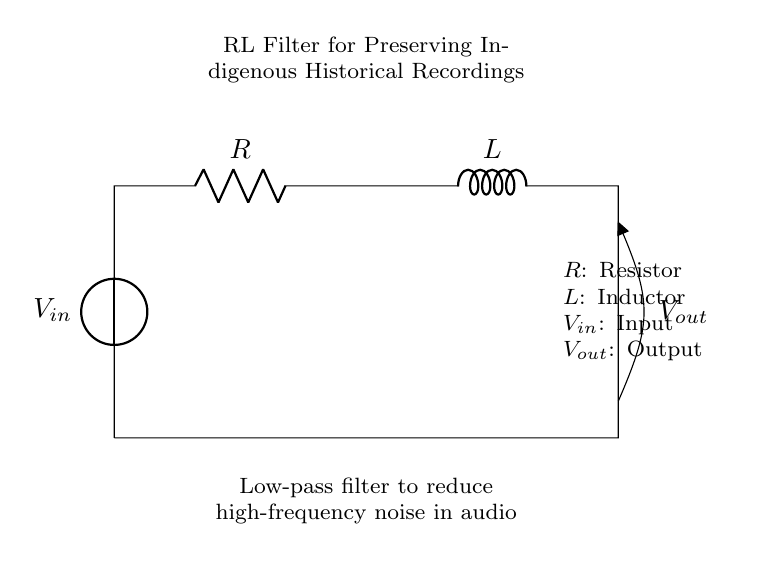What is the type of filter used in this circuit? The circuit uses a low-pass filter, as indicated by the design with a resistor and inductor, which allows low-frequency signals to pass while attenuating high-frequency signals.
Answer: Low-pass filter What component is labeled as 'R'? The component labeled 'R' is a resistor, which is used to limit the current flow in the circuit.
Answer: Resistor What component is labeled as 'L'? The component labeled 'L' is an inductor, which stores energy in a magnetic field when electrical current passes through it.
Answer: Inductor What is the significance of 'Vout' in this circuit? 'Vout' represents the output voltage of the circuit, which is taken across the inductor and indicates the filtered audio signal after passing through the low-pass filter.
Answer: Output voltage Why is a low-pass filter important for historical recordings? A low-pass filter is crucial for removing high-frequency noise from historical audio recordings, helping to preserve the clarity and quality of sounds relevant to indigenous cultures.
Answer: Preserves quality What happens to high-frequency signals in this circuit? High-frequency signals are attenuated or reduced as they pass through the circuit, meaning they are weakened and do not appear significantly at the output.
Answer: Attenuated 